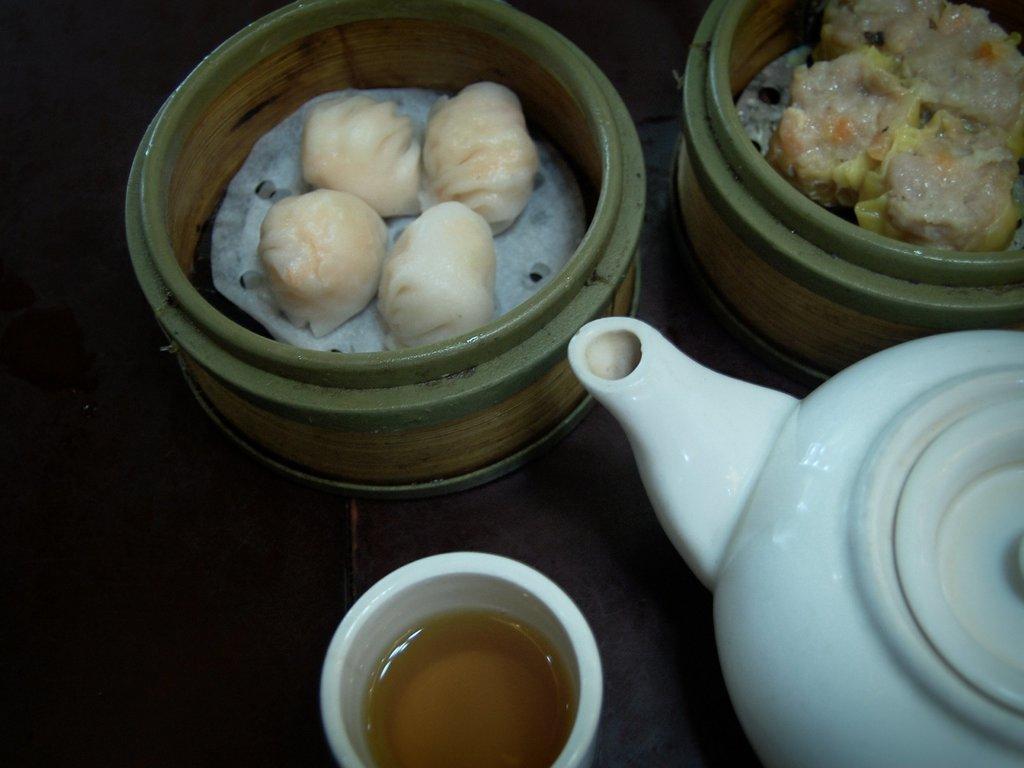Can you describe this image briefly? In this image we can see the bowls with some food and also we can see a tea pot and a glass with drink. 